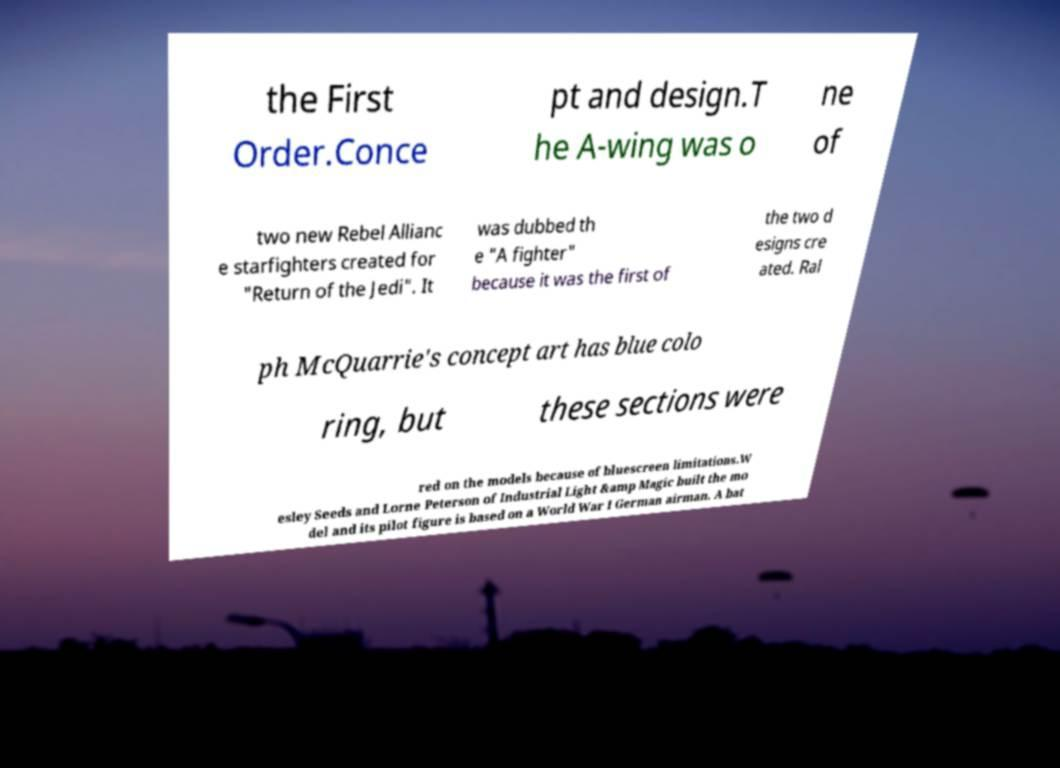Please identify and transcribe the text found in this image. the First Order.Conce pt and design.T he A-wing was o ne of two new Rebel Allianc e starfighters created for "Return of the Jedi". It was dubbed th e "A fighter" because it was the first of the two d esigns cre ated. Ral ph McQuarrie's concept art has blue colo ring, but these sections were red on the models because of bluescreen limitations.W esley Seeds and Lorne Peterson of Industrial Light &amp Magic built the mo del and its pilot figure is based on a World War I German airman. A bat 